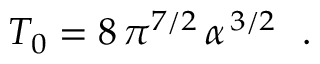<formula> <loc_0><loc_0><loc_500><loc_500>T _ { 0 } = 8 \, \pi ^ { 7 / 2 } \, \alpha ^ { \, 3 / 2 } .</formula> 